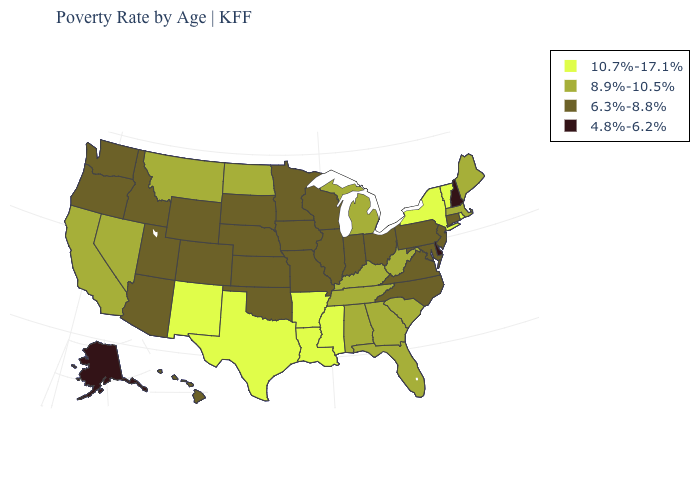Among the states that border Maine , which have the highest value?
Keep it brief. New Hampshire. What is the value of New York?
Short answer required. 10.7%-17.1%. What is the value of Montana?
Write a very short answer. 8.9%-10.5%. What is the lowest value in the USA?
Concise answer only. 4.8%-6.2%. Does Alaska have the highest value in the USA?
Answer briefly. No. Does the map have missing data?
Concise answer only. No. Among the states that border Kansas , which have the lowest value?
Answer briefly. Colorado, Missouri, Nebraska, Oklahoma. Does Maryland have a lower value than New Mexico?
Keep it brief. Yes. What is the value of Massachusetts?
Write a very short answer. 8.9%-10.5%. Name the states that have a value in the range 8.9%-10.5%?
Be succinct. Alabama, California, Florida, Georgia, Kentucky, Maine, Massachusetts, Michigan, Montana, Nevada, North Dakota, South Carolina, Tennessee, West Virginia. Which states hav the highest value in the West?
Short answer required. New Mexico. Does Louisiana have the same value as Vermont?
Short answer required. Yes. Name the states that have a value in the range 6.3%-8.8%?
Quick response, please. Arizona, Colorado, Connecticut, Hawaii, Idaho, Illinois, Indiana, Iowa, Kansas, Maryland, Minnesota, Missouri, Nebraska, New Jersey, North Carolina, Ohio, Oklahoma, Oregon, Pennsylvania, South Dakota, Utah, Virginia, Washington, Wisconsin, Wyoming. What is the value of California?
Concise answer only. 8.9%-10.5%. What is the highest value in the USA?
Short answer required. 10.7%-17.1%. 